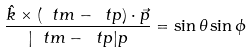<formula> <loc_0><loc_0><loc_500><loc_500>\frac { \hat { k } \times ( \ t m - \ t p ) \cdot \vec { p } } { | \ t m - \ t p | p } = \sin \theta \sin \phi</formula> 